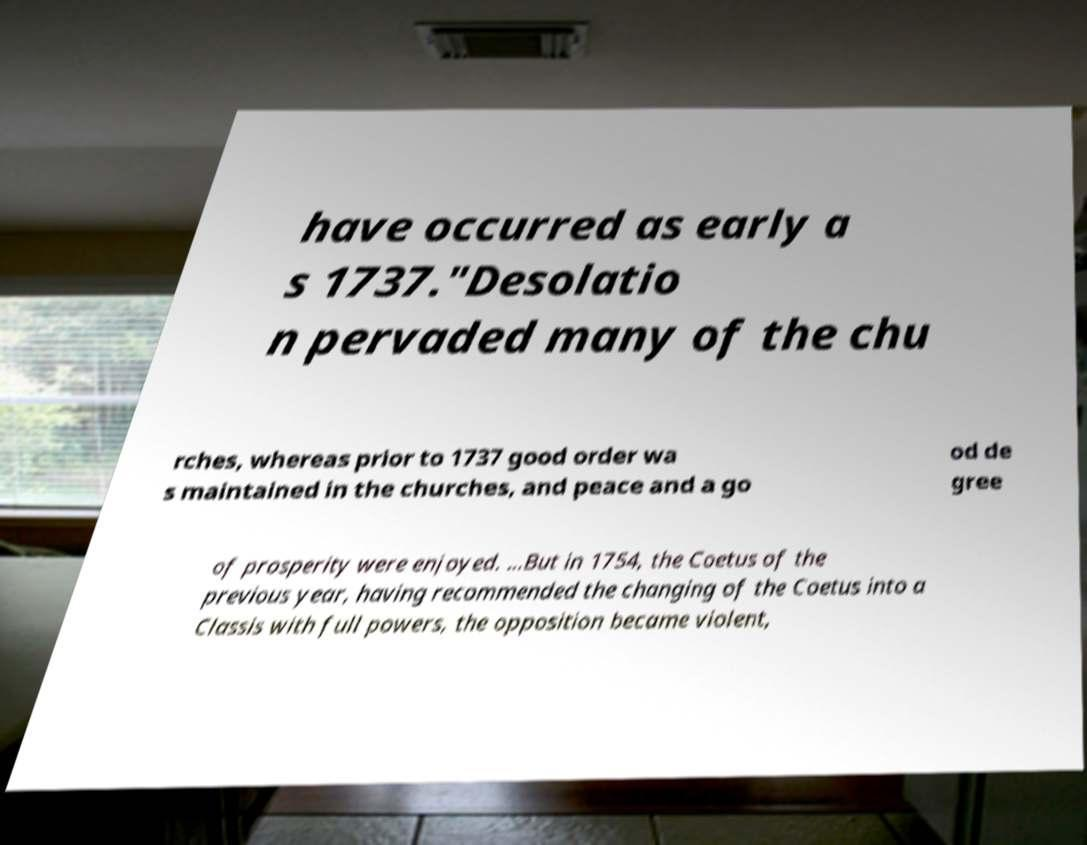Can you read and provide the text displayed in the image?This photo seems to have some interesting text. Can you extract and type it out for me? have occurred as early a s 1737."Desolatio n pervaded many of the chu rches, whereas prior to 1737 good order wa s maintained in the churches, and peace and a go od de gree of prosperity were enjoyed. ...But in 1754, the Coetus of the previous year, having recommended the changing of the Coetus into a Classis with full powers, the opposition became violent, 